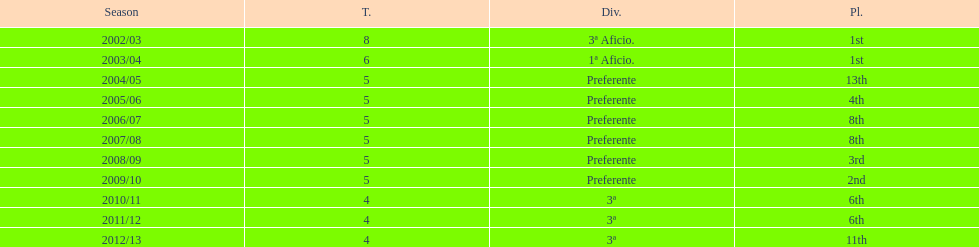In which year did the team attain the same position as they did in the 2010/11 season? 2011/12. 